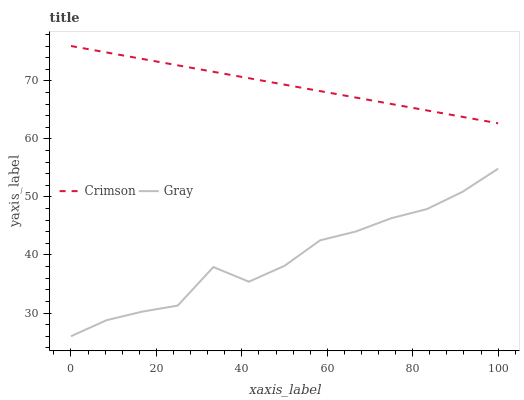Does Gray have the minimum area under the curve?
Answer yes or no. Yes. Does Crimson have the maximum area under the curve?
Answer yes or no. Yes. Does Gray have the maximum area under the curve?
Answer yes or no. No. Is Crimson the smoothest?
Answer yes or no. Yes. Is Gray the roughest?
Answer yes or no. Yes. Is Gray the smoothest?
Answer yes or no. No. Does Crimson have the highest value?
Answer yes or no. Yes. Does Gray have the highest value?
Answer yes or no. No. Is Gray less than Crimson?
Answer yes or no. Yes. Is Crimson greater than Gray?
Answer yes or no. Yes. Does Gray intersect Crimson?
Answer yes or no. No. 